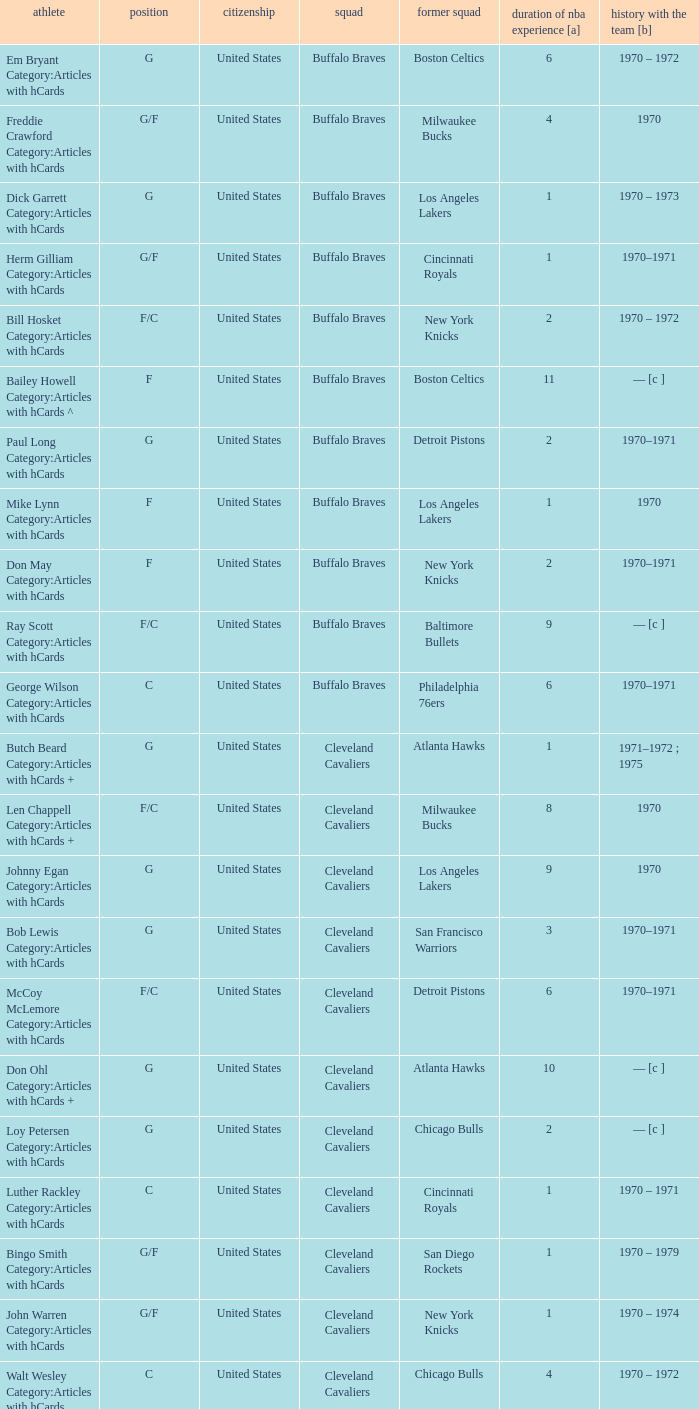Can you parse all the data within this table? {'header': ['athlete', 'position', 'citizenship', 'squad', 'former squad', 'duration of nba experience [a]', 'history with the team [b]'], 'rows': [['Em Bryant Category:Articles with hCards', 'G', 'United States', 'Buffalo Braves', 'Boston Celtics', '6', '1970 – 1972'], ['Freddie Crawford Category:Articles with hCards', 'G/F', 'United States', 'Buffalo Braves', 'Milwaukee Bucks', '4', '1970'], ['Dick Garrett Category:Articles with hCards', 'G', 'United States', 'Buffalo Braves', 'Los Angeles Lakers', '1', '1970 – 1973'], ['Herm Gilliam Category:Articles with hCards', 'G/F', 'United States', 'Buffalo Braves', 'Cincinnati Royals', '1', '1970–1971'], ['Bill Hosket Category:Articles with hCards', 'F/C', 'United States', 'Buffalo Braves', 'New York Knicks', '2', '1970 – 1972'], ['Bailey Howell Category:Articles with hCards ^', 'F', 'United States', 'Buffalo Braves', 'Boston Celtics', '11', '— [c ]'], ['Paul Long Category:Articles with hCards', 'G', 'United States', 'Buffalo Braves', 'Detroit Pistons', '2', '1970–1971'], ['Mike Lynn Category:Articles with hCards', 'F', 'United States', 'Buffalo Braves', 'Los Angeles Lakers', '1', '1970'], ['Don May Category:Articles with hCards', 'F', 'United States', 'Buffalo Braves', 'New York Knicks', '2', '1970–1971'], ['Ray Scott Category:Articles with hCards', 'F/C', 'United States', 'Buffalo Braves', 'Baltimore Bullets', '9', '— [c ]'], ['George Wilson Category:Articles with hCards', 'C', 'United States', 'Buffalo Braves', 'Philadelphia 76ers', '6', '1970–1971'], ['Butch Beard Category:Articles with hCards +', 'G', 'United States', 'Cleveland Cavaliers', 'Atlanta Hawks', '1', '1971–1972 ; 1975'], ['Len Chappell Category:Articles with hCards +', 'F/C', 'United States', 'Cleveland Cavaliers', 'Milwaukee Bucks', '8', '1970'], ['Johnny Egan Category:Articles with hCards', 'G', 'United States', 'Cleveland Cavaliers', 'Los Angeles Lakers', '9', '1970'], ['Bob Lewis Category:Articles with hCards', 'G', 'United States', 'Cleveland Cavaliers', 'San Francisco Warriors', '3', '1970–1971'], ['McCoy McLemore Category:Articles with hCards', 'F/C', 'United States', 'Cleveland Cavaliers', 'Detroit Pistons', '6', '1970–1971'], ['Don Ohl Category:Articles with hCards +', 'G', 'United States', 'Cleveland Cavaliers', 'Atlanta Hawks', '10', '— [c ]'], ['Loy Petersen Category:Articles with hCards', 'G', 'United States', 'Cleveland Cavaliers', 'Chicago Bulls', '2', '— [c ]'], ['Luther Rackley Category:Articles with hCards', 'C', 'United States', 'Cleveland Cavaliers', 'Cincinnati Royals', '1', '1970 – 1971'], ['Bingo Smith Category:Articles with hCards', 'G/F', 'United States', 'Cleveland Cavaliers', 'San Diego Rockets', '1', '1970 – 1979'], ['John Warren Category:Articles with hCards', 'G/F', 'United States', 'Cleveland Cavaliers', 'New York Knicks', '1', '1970 – 1974'], ['Walt Wesley Category:Articles with hCards', 'C', 'United States', 'Cleveland Cavaliers', 'Chicago Bulls', '4', '1970 – 1972'], ['Rick Adelman Category:Articles with hCards', 'G', 'United States', 'Portland Trail Blazers', 'San Diego Rockets', '2', '1970 – 1973'], ['Jerry Chambers Category:Articles with hCards', 'F', 'United States', 'Portland Trail Blazers', 'Phoenix Suns', '2', '— [c ]'], ['LeRoy Ellis Category:Articles with hCards', 'F/C', 'United States', 'Portland Trail Blazers', 'Baltimore Bullets', '8', '1970–1971'], ['Fred Hetzel Category:Articles with hCards', 'F/C', 'United States', 'Portland Trail Blazers', 'Philadelphia 76ers', '5', '— [c ]'], ['Joe Kennedy Category:Articles with hCards', 'F', 'United States', 'Portland Trail Blazers', 'Seattle SuperSonics', '2', '— [c ]'], ['Ed Manning Category:Articles with hCards', 'F', 'United States', 'Portland Trail Blazers', 'Chicago Bulls', '3', '1970–1971'], ['Stan McKenzie Category:Articles with hCards', 'G/F', 'United States', 'Portland Trail Blazers', 'Phoenix Suns', '3', '1970 – 1972'], ['Dorie Murrey Category:Articles with hCards', 'F/C', 'United States', 'Portland Trail Blazers', 'Seattle SuperSonics', '4', '1970'], ['Pat Riley Category:Articles with hCards', 'G/F', 'United States', 'Portland Trail Blazers', 'San Diego Rockets', '3', '— [c ]'], ['Dale Schlueter Category:Articles with hCards', 'C', 'United States', 'Portland Trail Blazers', 'San Francisco Warriors', '2', '1970 – 1972 ; 1977–1978'], ['Larry Siegfried Category:Articles with hCards', 'F', 'United States', 'Portland Trail Blazers', 'Boston Celtics', '7', '— [c ]']]} Who is the player from the Buffalo Braves with the previous team Los Angeles Lakers and a career with the franchase in 1970? Mike Lynn Category:Articles with hCards. 